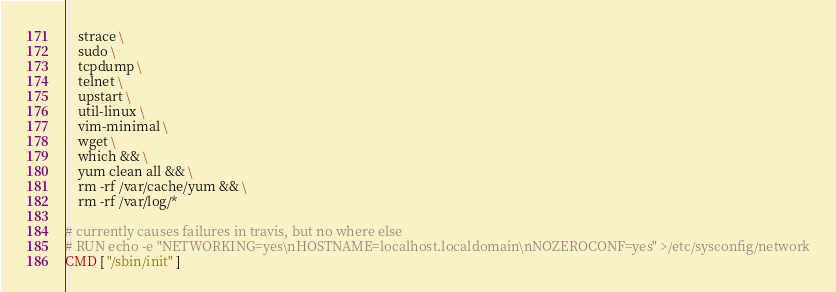<code> <loc_0><loc_0><loc_500><loc_500><_Dockerfile_>    strace \
    sudo \
    tcpdump \
    telnet \
    upstart \
    util-linux \
    vim-minimal \
    wget \
    which && \
    yum clean all && \
    rm -rf /var/cache/yum && \
    rm -rf /var/log/*

# currently causes failures in travis, but no where else
# RUN echo -e "NETWORKING=yes\nHOSTNAME=localhost.localdomain\nNOZEROCONF=yes" >/etc/sysconfig/network
CMD [ "/sbin/init" ]
</code> 